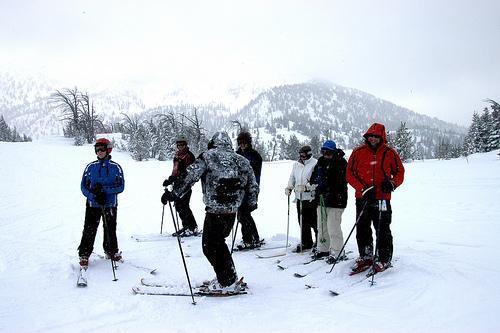How many people are there?
Give a very brief answer. 7. 